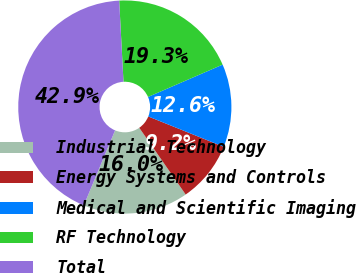Convert chart to OTSL. <chart><loc_0><loc_0><loc_500><loc_500><pie_chart><fcel>Industrial Technology<fcel>Energy Systems and Controls<fcel>Medical and Scientific Imaging<fcel>RF Technology<fcel>Total<nl><fcel>15.96%<fcel>9.24%<fcel>12.6%<fcel>19.33%<fcel>42.87%<nl></chart> 